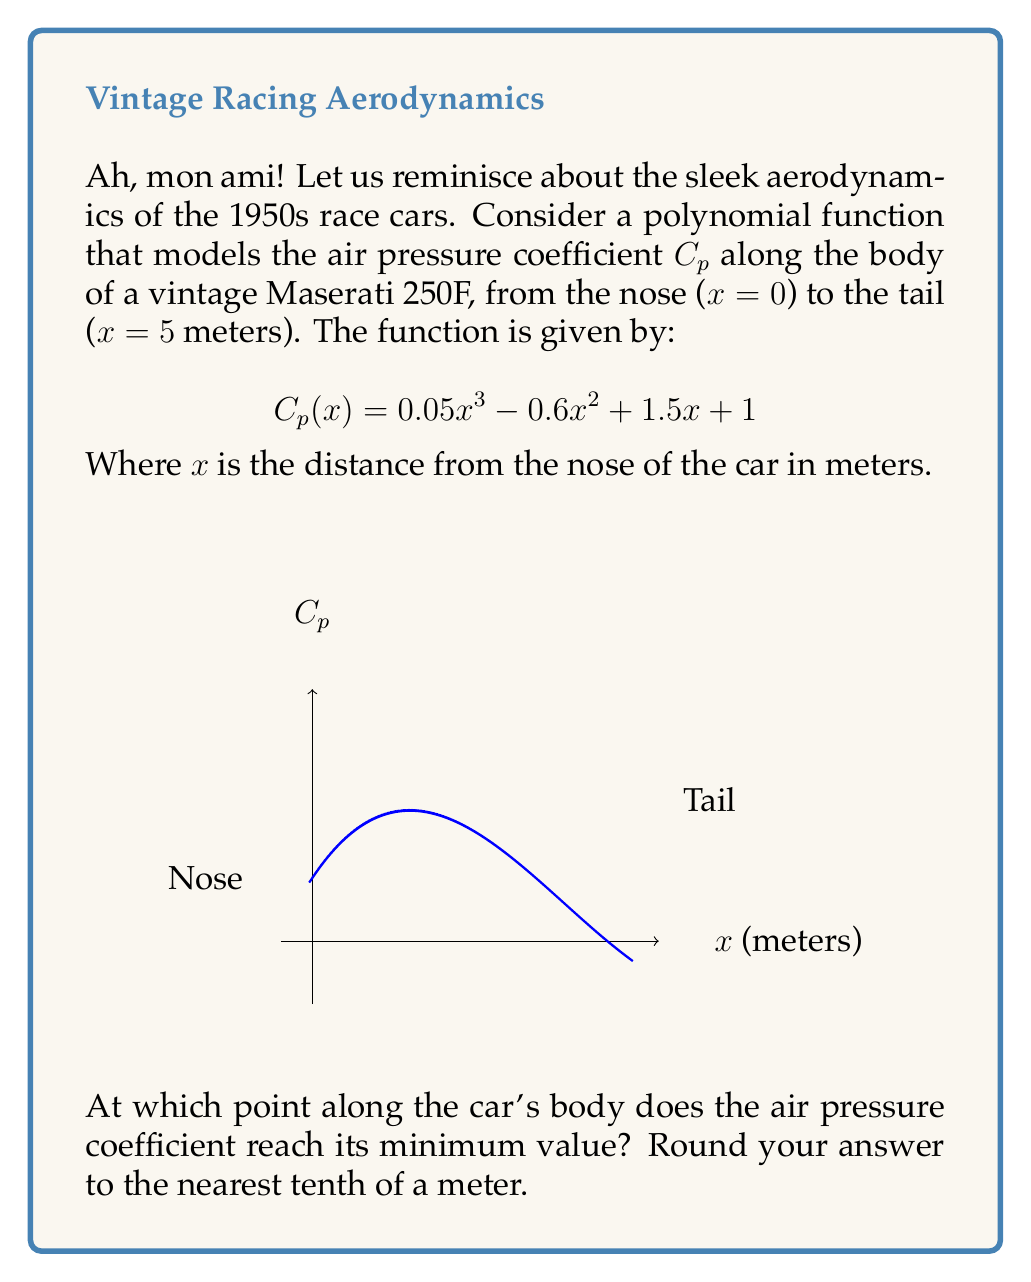Teach me how to tackle this problem. To find the minimum value of the air pressure coefficient, we need to follow these steps:

1) First, we need to find the derivative of $C_p(x)$:
   $$C_p'(x) = 0.15x^2 - 1.2x + 1.5$$

2) To find the minimum, we set $C_p'(x) = 0$ and solve for x:
   $$0.15x^2 - 1.2x + 1.5 = 0$$

3) This is a quadratic equation. We can solve it using the quadratic formula:
   $$x = \frac{-b \pm \sqrt{b^2 - 4ac}}{2a}$$
   Where $a = 0.15$, $b = -1.2$, and $c = 1.5$

4) Plugging in these values:
   $$x = \frac{1.2 \pm \sqrt{(-1.2)^2 - 4(0.15)(1.5)}}{2(0.15)}$$
   $$= \frac{1.2 \pm \sqrt{1.44 - 0.9}}{0.3}$$
   $$= \frac{1.2 \pm \sqrt{0.54}}{0.3}$$
   $$= \frac{1.2 \pm 0.7348}{0.3}$$

5) This gives us two solutions:
   $$x_1 = \frac{1.2 + 0.7348}{0.3} \approx 6.45$$
   $$x_2 = \frac{1.2 - 0.7348}{0.3} \approx 1.55$$

6) Since the car is only 5 meters long, the solution x ≈ 6.45 is outside our domain.

7) Therefore, the minimum occurs at x ≈ 1.55 meters from the nose of the car.

8) Rounding to the nearest tenth: 1.6 meters.
Answer: 1.6 meters 